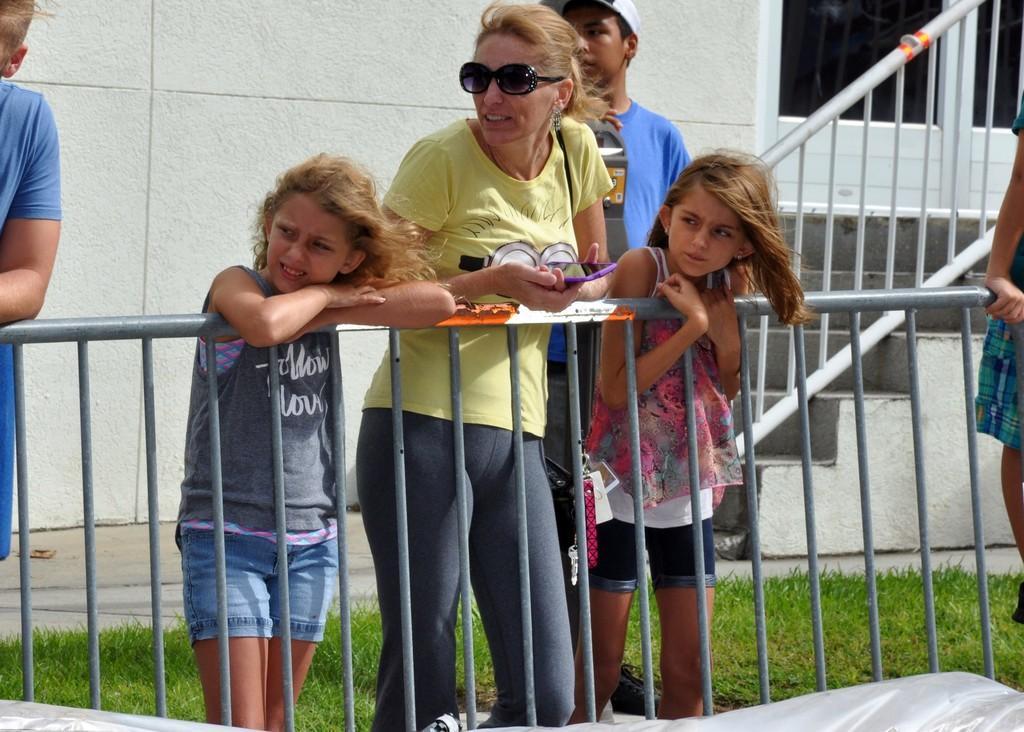Could you give a brief overview of what you see in this image? In front of the picture, we see a woman in yellow T-shirt who is wearing goggles is holding a mobile phone in her hands. Beside her, we see two children are standing. In front of them, we see an iron railing. Behind her, we see a man in blue T-shirt is standing. Beside him, we see a staircase and a stair railing. In the background, we see a white wall and a white door. The man on the left side is standing. At the bottom of the picture, we see a silver color sheet and the grass. 